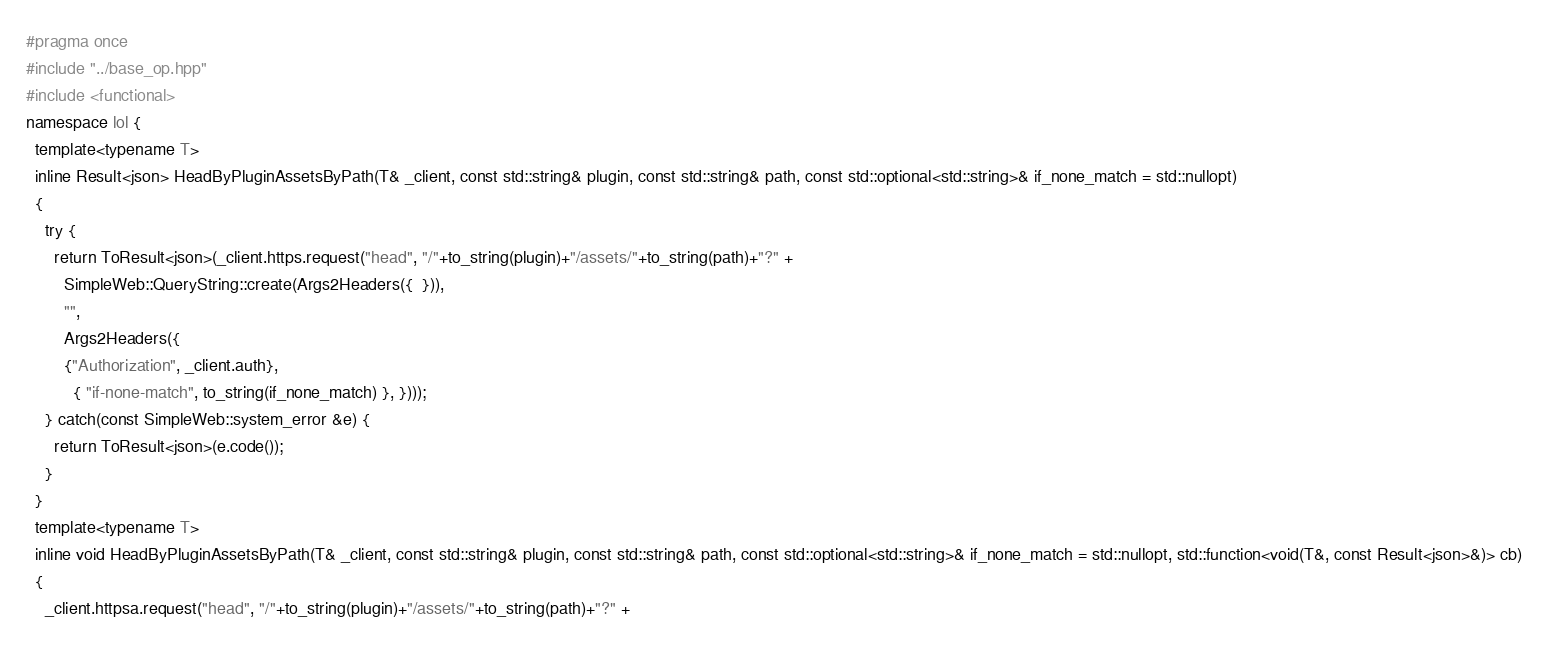Convert code to text. <code><loc_0><loc_0><loc_500><loc_500><_C++_>#pragma once
#include "../base_op.hpp"
#include <functional> 
namespace lol {
  template<typename T>
  inline Result<json> HeadByPluginAssetsByPath(T& _client, const std::string& plugin, const std::string& path, const std::optional<std::string>& if_none_match = std::nullopt)
  {
    try {
      return ToResult<json>(_client.https.request("head", "/"+to_string(plugin)+"/assets/"+to_string(path)+"?" +
        SimpleWeb::QueryString::create(Args2Headers({  })), 
        "",
        Args2Headers({  
        {"Authorization", _client.auth}, 
          { "if-none-match", to_string(if_none_match) }, })));
    } catch(const SimpleWeb::system_error &e) {
      return ToResult<json>(e.code());
    }
  }
  template<typename T>
  inline void HeadByPluginAssetsByPath(T& _client, const std::string& plugin, const std::string& path, const std::optional<std::string>& if_none_match = std::nullopt, std::function<void(T&, const Result<json>&)> cb)
  {
    _client.httpsa.request("head", "/"+to_string(plugin)+"/assets/"+to_string(path)+"?" +</code> 